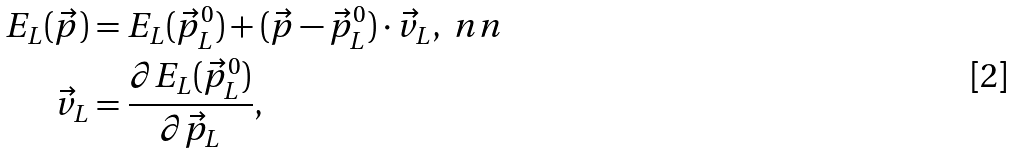Convert formula to latex. <formula><loc_0><loc_0><loc_500><loc_500>E _ { L } ( { \vec { p } } ) & = E _ { L } ( { \vec { p } } _ { L } ^ { 0 } ) + ( \vec { p } - \vec { p } ^ { 0 } _ { L } ) \cdot \vec { v } _ { L } , \ n n \\ \vec { v } _ { L } & = \frac { \partial E _ { L } ( \vec { p } _ { L } ^ { 0 } ) } { \partial \vec { p } _ { L } } ,</formula> 